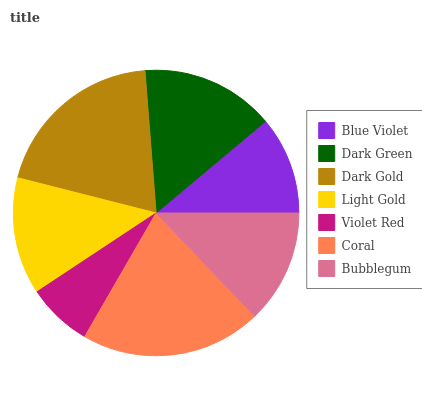Is Violet Red the minimum?
Answer yes or no. Yes. Is Coral the maximum?
Answer yes or no. Yes. Is Dark Green the minimum?
Answer yes or no. No. Is Dark Green the maximum?
Answer yes or no. No. Is Dark Green greater than Blue Violet?
Answer yes or no. Yes. Is Blue Violet less than Dark Green?
Answer yes or no. Yes. Is Blue Violet greater than Dark Green?
Answer yes or no. No. Is Dark Green less than Blue Violet?
Answer yes or no. No. Is Light Gold the high median?
Answer yes or no. Yes. Is Light Gold the low median?
Answer yes or no. Yes. Is Violet Red the high median?
Answer yes or no. No. Is Dark Gold the low median?
Answer yes or no. No. 